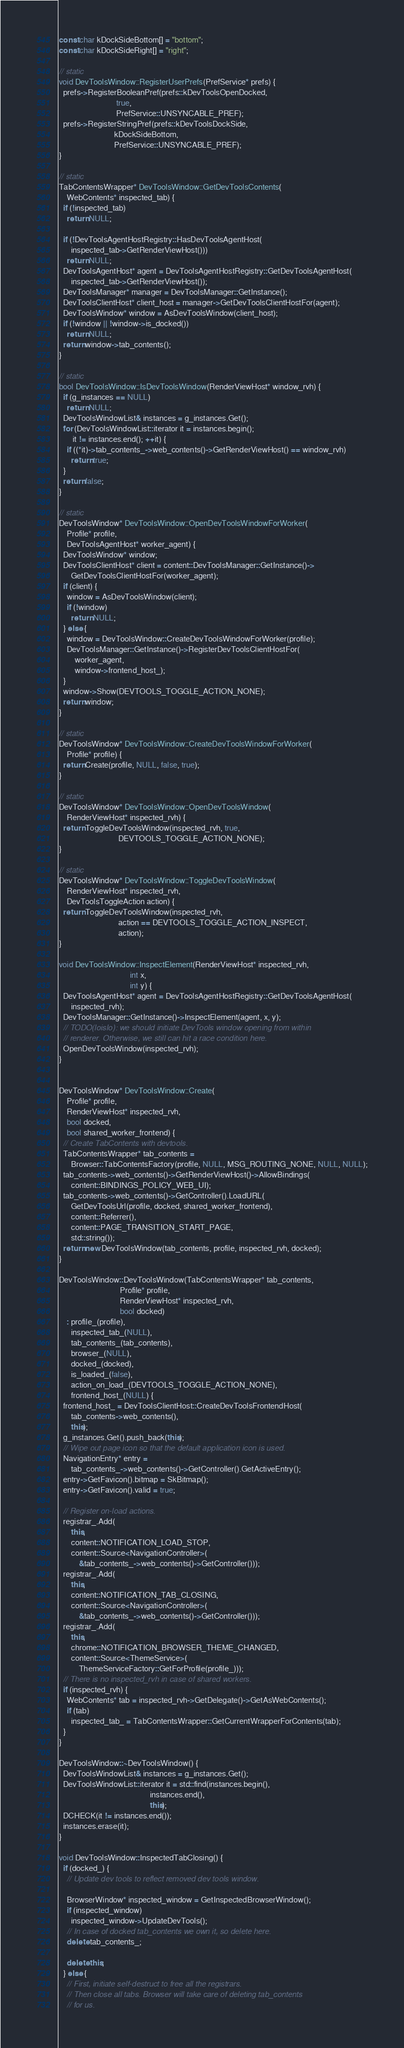<code> <loc_0><loc_0><loc_500><loc_500><_C++_>
const char kDockSideBottom[] = "bottom";
const char kDockSideRight[] = "right";

// static
void DevToolsWindow::RegisterUserPrefs(PrefService* prefs) {
  prefs->RegisterBooleanPref(prefs::kDevToolsOpenDocked,
                             true,
                             PrefService::UNSYNCABLE_PREF);
  prefs->RegisterStringPref(prefs::kDevToolsDockSide,
                            kDockSideBottom,
                            PrefService::UNSYNCABLE_PREF);
}

// static
TabContentsWrapper* DevToolsWindow::GetDevToolsContents(
    WebContents* inspected_tab) {
  if (!inspected_tab)
    return NULL;

  if (!DevToolsAgentHostRegistry::HasDevToolsAgentHost(
      inspected_tab->GetRenderViewHost()))
    return NULL;
  DevToolsAgentHost* agent = DevToolsAgentHostRegistry::GetDevToolsAgentHost(
      inspected_tab->GetRenderViewHost());
  DevToolsManager* manager = DevToolsManager::GetInstance();
  DevToolsClientHost* client_host = manager->GetDevToolsClientHostFor(agent);
  DevToolsWindow* window = AsDevToolsWindow(client_host);
  if (!window || !window->is_docked())
    return NULL;
  return window->tab_contents();
}

// static
bool DevToolsWindow::IsDevToolsWindow(RenderViewHost* window_rvh) {
  if (g_instances == NULL)
    return NULL;
  DevToolsWindowList& instances = g_instances.Get();
  for (DevToolsWindowList::iterator it = instances.begin();
       it != instances.end(); ++it) {
    if ((*it)->tab_contents_->web_contents()->GetRenderViewHost() == window_rvh)
      return true;
  }
  return false;
}

// static
DevToolsWindow* DevToolsWindow::OpenDevToolsWindowForWorker(
    Profile* profile,
    DevToolsAgentHost* worker_agent) {
  DevToolsWindow* window;
  DevToolsClientHost* client = content::DevToolsManager::GetInstance()->
      GetDevToolsClientHostFor(worker_agent);
  if (client) {
    window = AsDevToolsWindow(client);
    if (!window)
      return NULL;
  } else {
    window = DevToolsWindow::CreateDevToolsWindowForWorker(profile);
    DevToolsManager::GetInstance()->RegisterDevToolsClientHostFor(
        worker_agent,
        window->frontend_host_);
  }
  window->Show(DEVTOOLS_TOGGLE_ACTION_NONE);
  return window;
}

// static
DevToolsWindow* DevToolsWindow::CreateDevToolsWindowForWorker(
    Profile* profile) {
  return Create(profile, NULL, false, true);
}

// static
DevToolsWindow* DevToolsWindow::OpenDevToolsWindow(
    RenderViewHost* inspected_rvh) {
  return ToggleDevToolsWindow(inspected_rvh, true,
                              DEVTOOLS_TOGGLE_ACTION_NONE);
}

// static
DevToolsWindow* DevToolsWindow::ToggleDevToolsWindow(
    RenderViewHost* inspected_rvh,
    DevToolsToggleAction action) {
  return ToggleDevToolsWindow(inspected_rvh,
                              action == DEVTOOLS_TOGGLE_ACTION_INSPECT,
                              action);
}

void DevToolsWindow::InspectElement(RenderViewHost* inspected_rvh,
                                    int x,
                                    int y) {
  DevToolsAgentHost* agent = DevToolsAgentHostRegistry::GetDevToolsAgentHost(
      inspected_rvh);
  DevToolsManager::GetInstance()->InspectElement(agent, x, y);
  // TODO(loislo): we should initiate DevTools window opening from within
  // renderer. Otherwise, we still can hit a race condition here.
  OpenDevToolsWindow(inspected_rvh);
}


DevToolsWindow* DevToolsWindow::Create(
    Profile* profile,
    RenderViewHost* inspected_rvh,
    bool docked,
    bool shared_worker_frontend) {
  // Create TabContents with devtools.
  TabContentsWrapper* tab_contents =
      Browser::TabContentsFactory(profile, NULL, MSG_ROUTING_NONE, NULL, NULL);
  tab_contents->web_contents()->GetRenderViewHost()->AllowBindings(
      content::BINDINGS_POLICY_WEB_UI);
  tab_contents->web_contents()->GetController().LoadURL(
      GetDevToolsUrl(profile, docked, shared_worker_frontend),
      content::Referrer(),
      content::PAGE_TRANSITION_START_PAGE,
      std::string());
  return new DevToolsWindow(tab_contents, profile, inspected_rvh, docked);
}

DevToolsWindow::DevToolsWindow(TabContentsWrapper* tab_contents,
                               Profile* profile,
                               RenderViewHost* inspected_rvh,
                               bool docked)
    : profile_(profile),
      inspected_tab_(NULL),
      tab_contents_(tab_contents),
      browser_(NULL),
      docked_(docked),
      is_loaded_(false),
      action_on_load_(DEVTOOLS_TOGGLE_ACTION_NONE),
      frontend_host_(NULL) {
  frontend_host_ = DevToolsClientHost::CreateDevToolsFrontendHost(
      tab_contents->web_contents(),
      this);
  g_instances.Get().push_back(this);
  // Wipe out page icon so that the default application icon is used.
  NavigationEntry* entry =
      tab_contents_->web_contents()->GetController().GetActiveEntry();
  entry->GetFavicon().bitmap = SkBitmap();
  entry->GetFavicon().valid = true;

  // Register on-load actions.
  registrar_.Add(
      this,
      content::NOTIFICATION_LOAD_STOP,
      content::Source<NavigationController>(
          &tab_contents_->web_contents()->GetController()));
  registrar_.Add(
      this,
      content::NOTIFICATION_TAB_CLOSING,
      content::Source<NavigationController>(
          &tab_contents_->web_contents()->GetController()));
  registrar_.Add(
      this,
      chrome::NOTIFICATION_BROWSER_THEME_CHANGED,
      content::Source<ThemeService>(
          ThemeServiceFactory::GetForProfile(profile_)));
  // There is no inspected_rvh in case of shared workers.
  if (inspected_rvh) {
    WebContents* tab = inspected_rvh->GetDelegate()->GetAsWebContents();
    if (tab)
      inspected_tab_ = TabContentsWrapper::GetCurrentWrapperForContents(tab);
  }
}

DevToolsWindow::~DevToolsWindow() {
  DevToolsWindowList& instances = g_instances.Get();
  DevToolsWindowList::iterator it = std::find(instances.begin(),
                                              instances.end(),
                                              this);
  DCHECK(it != instances.end());
  instances.erase(it);
}

void DevToolsWindow::InspectedTabClosing() {
  if (docked_) {
    // Update dev tools to reflect removed dev tools window.

    BrowserWindow* inspected_window = GetInspectedBrowserWindow();
    if (inspected_window)
      inspected_window->UpdateDevTools();
    // In case of docked tab_contents we own it, so delete here.
    delete tab_contents_;

    delete this;
  } else {
    // First, initiate self-destruct to free all the registrars.
    // Then close all tabs. Browser will take care of deleting tab_contents
    // for us.</code> 